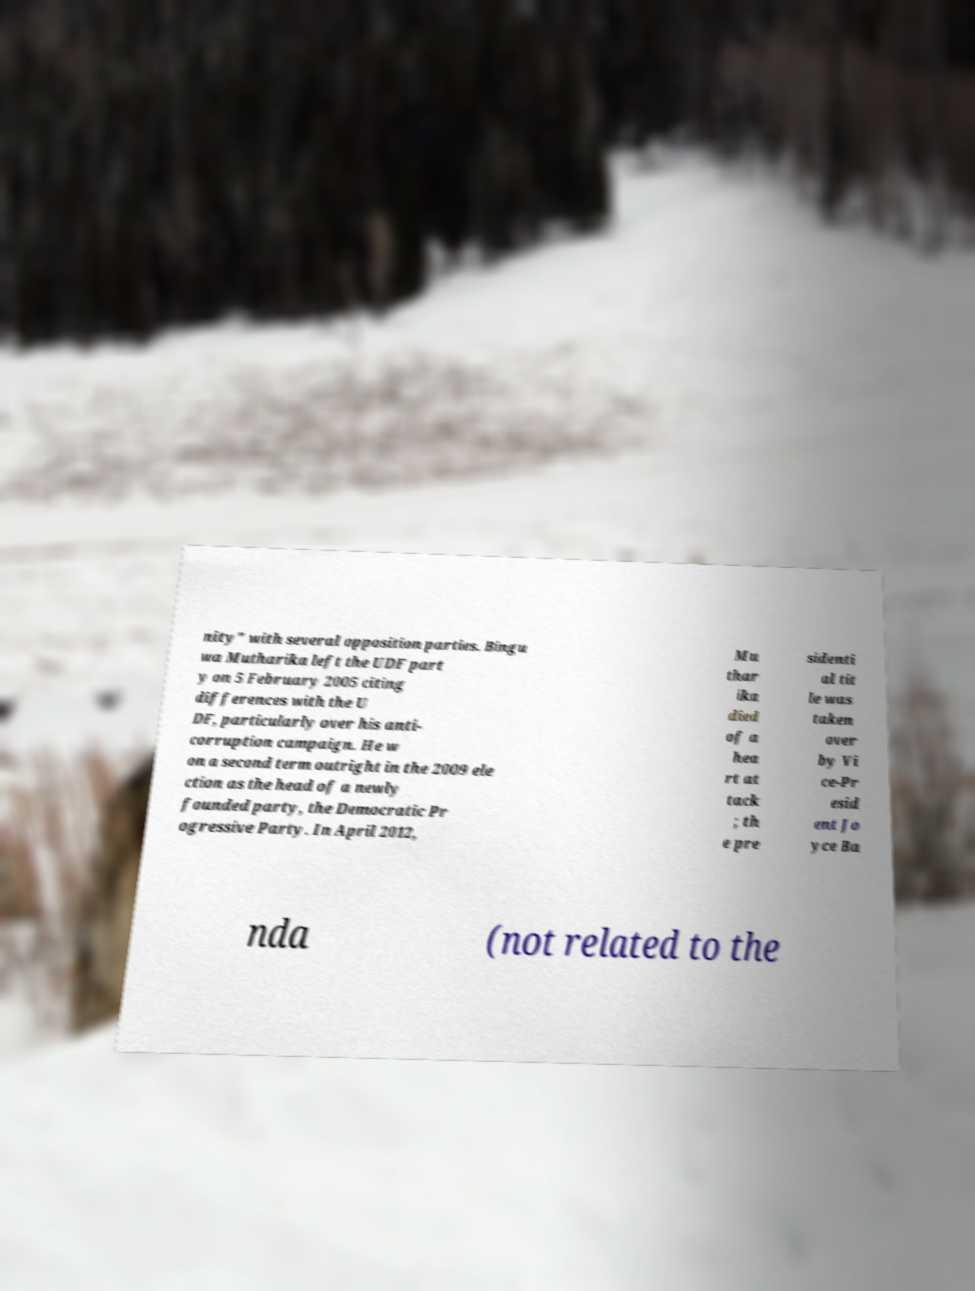Could you assist in decoding the text presented in this image and type it out clearly? nity" with several opposition parties. Bingu wa Mutharika left the UDF part y on 5 February 2005 citing differences with the U DF, particularly over his anti- corruption campaign. He w on a second term outright in the 2009 ele ction as the head of a newly founded party, the Democratic Pr ogressive Party. In April 2012, Mu thar ika died of a hea rt at tack ; th e pre sidenti al tit le was taken over by Vi ce-Pr esid ent Jo yce Ba nda (not related to the 